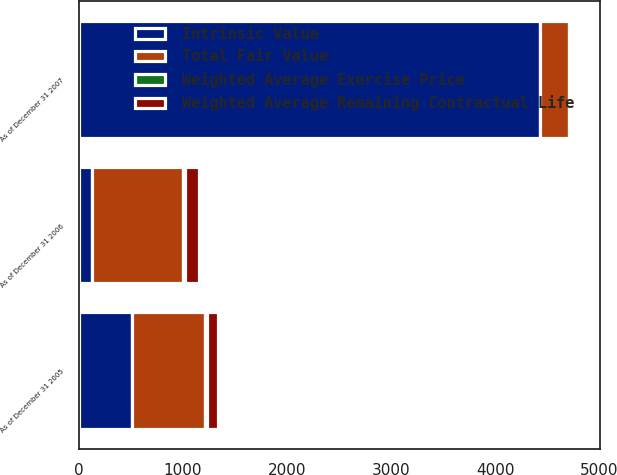Convert chart to OTSL. <chart><loc_0><loc_0><loc_500><loc_500><stacked_bar_chart><ecel><fcel>As of December 31 2005<fcel>As of December 31 2006<fcel>As of December 31 2007<nl><fcel>Weighted Average Remaining Contractual Life<fcel>112<fcel>132<fcel>35<nl><fcel>Total Fair Value<fcel>704<fcel>872<fcel>280<nl><fcel>Weighted Average Exercise Price<fcel>14.97<fcel>16.45<fcel>21.75<nl><fcel>Intrinsic Value<fcel>509<fcel>132<fcel>4432<nl></chart> 